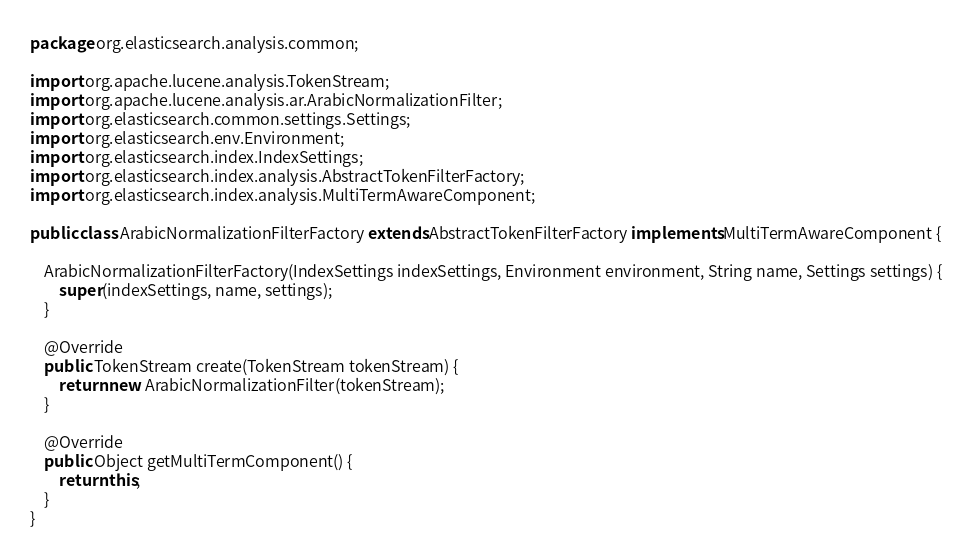Convert code to text. <code><loc_0><loc_0><loc_500><loc_500><_Java_>package org.elasticsearch.analysis.common;

import org.apache.lucene.analysis.TokenStream;
import org.apache.lucene.analysis.ar.ArabicNormalizationFilter;
import org.elasticsearch.common.settings.Settings;
import org.elasticsearch.env.Environment;
import org.elasticsearch.index.IndexSettings;
import org.elasticsearch.index.analysis.AbstractTokenFilterFactory;
import org.elasticsearch.index.analysis.MultiTermAwareComponent;

public class ArabicNormalizationFilterFactory extends AbstractTokenFilterFactory implements MultiTermAwareComponent {

    ArabicNormalizationFilterFactory(IndexSettings indexSettings, Environment environment, String name, Settings settings) {
        super(indexSettings, name, settings);
    }

    @Override
    public TokenStream create(TokenStream tokenStream) {
        return new ArabicNormalizationFilter(tokenStream);
    }

    @Override
    public Object getMultiTermComponent() {
        return this;
    }
}
</code> 